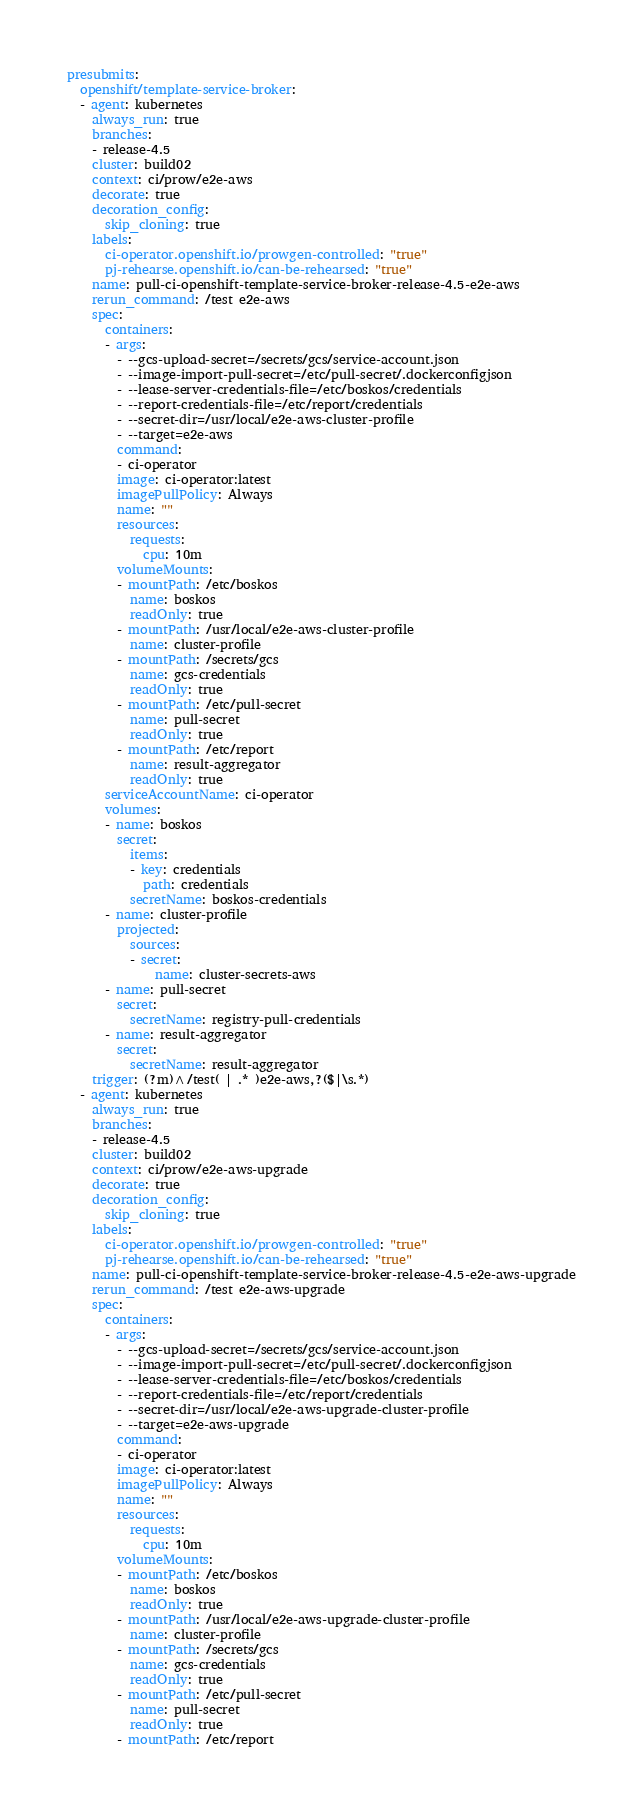<code> <loc_0><loc_0><loc_500><loc_500><_YAML_>presubmits:
  openshift/template-service-broker:
  - agent: kubernetes
    always_run: true
    branches:
    - release-4.5
    cluster: build02
    context: ci/prow/e2e-aws
    decorate: true
    decoration_config:
      skip_cloning: true
    labels:
      ci-operator.openshift.io/prowgen-controlled: "true"
      pj-rehearse.openshift.io/can-be-rehearsed: "true"
    name: pull-ci-openshift-template-service-broker-release-4.5-e2e-aws
    rerun_command: /test e2e-aws
    spec:
      containers:
      - args:
        - --gcs-upload-secret=/secrets/gcs/service-account.json
        - --image-import-pull-secret=/etc/pull-secret/.dockerconfigjson
        - --lease-server-credentials-file=/etc/boskos/credentials
        - --report-credentials-file=/etc/report/credentials
        - --secret-dir=/usr/local/e2e-aws-cluster-profile
        - --target=e2e-aws
        command:
        - ci-operator
        image: ci-operator:latest
        imagePullPolicy: Always
        name: ""
        resources:
          requests:
            cpu: 10m
        volumeMounts:
        - mountPath: /etc/boskos
          name: boskos
          readOnly: true
        - mountPath: /usr/local/e2e-aws-cluster-profile
          name: cluster-profile
        - mountPath: /secrets/gcs
          name: gcs-credentials
          readOnly: true
        - mountPath: /etc/pull-secret
          name: pull-secret
          readOnly: true
        - mountPath: /etc/report
          name: result-aggregator
          readOnly: true
      serviceAccountName: ci-operator
      volumes:
      - name: boskos
        secret:
          items:
          - key: credentials
            path: credentials
          secretName: boskos-credentials
      - name: cluster-profile
        projected:
          sources:
          - secret:
              name: cluster-secrets-aws
      - name: pull-secret
        secret:
          secretName: registry-pull-credentials
      - name: result-aggregator
        secret:
          secretName: result-aggregator
    trigger: (?m)^/test( | .* )e2e-aws,?($|\s.*)
  - agent: kubernetes
    always_run: true
    branches:
    - release-4.5
    cluster: build02
    context: ci/prow/e2e-aws-upgrade
    decorate: true
    decoration_config:
      skip_cloning: true
    labels:
      ci-operator.openshift.io/prowgen-controlled: "true"
      pj-rehearse.openshift.io/can-be-rehearsed: "true"
    name: pull-ci-openshift-template-service-broker-release-4.5-e2e-aws-upgrade
    rerun_command: /test e2e-aws-upgrade
    spec:
      containers:
      - args:
        - --gcs-upload-secret=/secrets/gcs/service-account.json
        - --image-import-pull-secret=/etc/pull-secret/.dockerconfigjson
        - --lease-server-credentials-file=/etc/boskos/credentials
        - --report-credentials-file=/etc/report/credentials
        - --secret-dir=/usr/local/e2e-aws-upgrade-cluster-profile
        - --target=e2e-aws-upgrade
        command:
        - ci-operator
        image: ci-operator:latest
        imagePullPolicy: Always
        name: ""
        resources:
          requests:
            cpu: 10m
        volumeMounts:
        - mountPath: /etc/boskos
          name: boskos
          readOnly: true
        - mountPath: /usr/local/e2e-aws-upgrade-cluster-profile
          name: cluster-profile
        - mountPath: /secrets/gcs
          name: gcs-credentials
          readOnly: true
        - mountPath: /etc/pull-secret
          name: pull-secret
          readOnly: true
        - mountPath: /etc/report</code> 